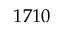<formula> <loc_0><loc_0><loc_500><loc_500>1 7 1 0</formula> 